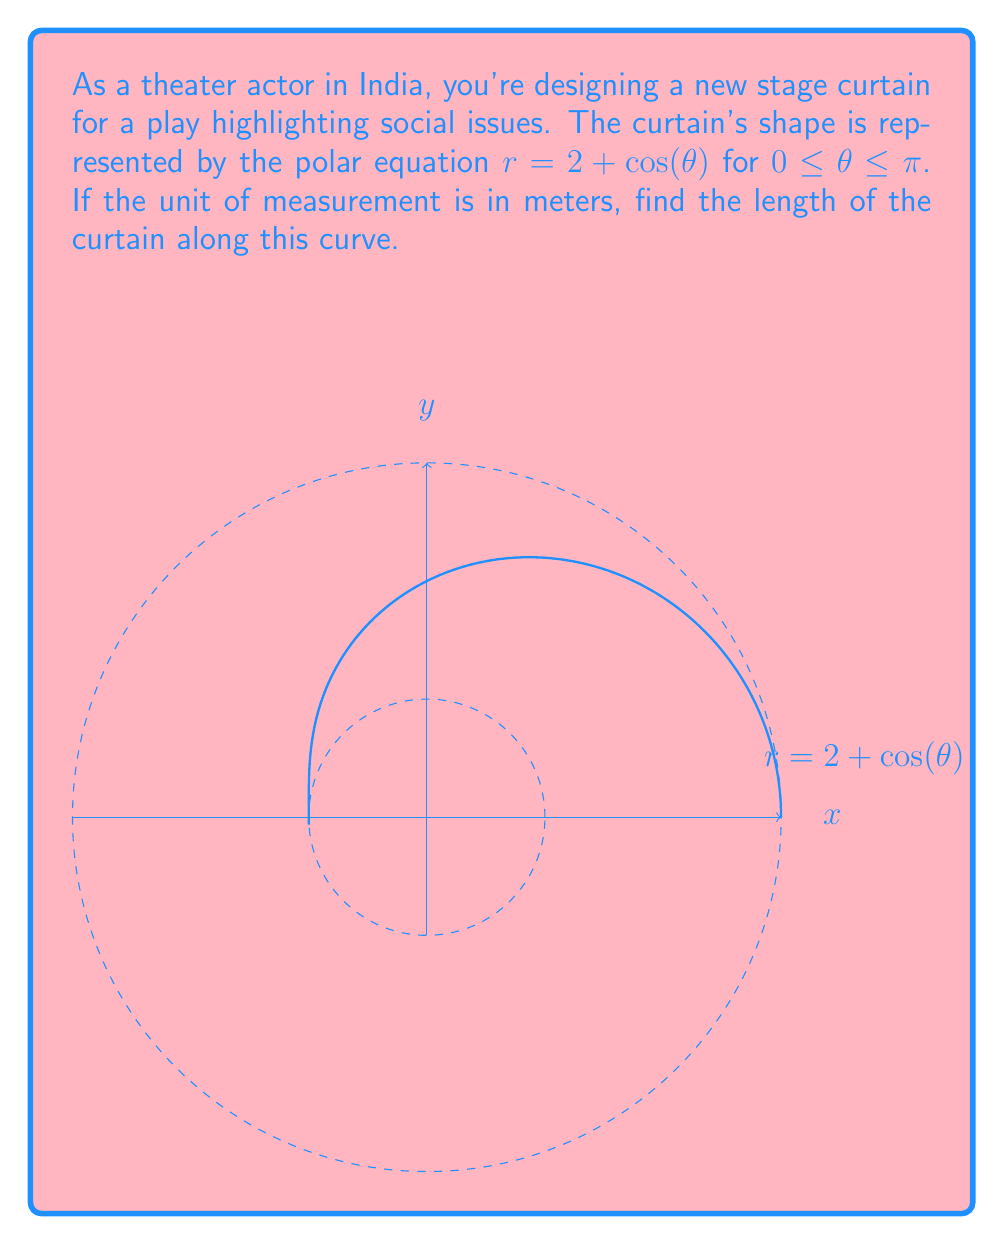Teach me how to tackle this problem. To find the length of the curved curtain, we need to use the arc length formula for polar equations:

$$ L = \int_a^b \sqrt{r^2 + \left(\frac{dr}{d\theta}\right)^2} d\theta $$

Where $r = 2 + \cos(\theta)$ and $0 \leq \theta \leq \pi$

Step 1: Find $\frac{dr}{d\theta}$
$$ \frac{dr}{d\theta} = -\sin(\theta) $$

Step 2: Substitute into the arc length formula
$$ L = \int_0^\pi \sqrt{(2+\cos(\theta))^2 + (-\sin(\theta))^2} d\theta $$

Step 3: Simplify the expression under the square root
$$ L = \int_0^\pi \sqrt{4 + 4\cos(\theta) + \cos^2(\theta) + \sin^2(\theta)} d\theta $$
$$ L = \int_0^\pi \sqrt{5 + 4\cos(\theta)} d\theta $$

Step 4: This integral cannot be evaluated in terms of elementary functions. We need to use numerical integration methods to approximate the result.

Using a computational tool or calculator with numerical integration capabilities, we find:

$$ L \approx 7.6394 \text{ meters} $$
Answer: $7.6394$ meters 